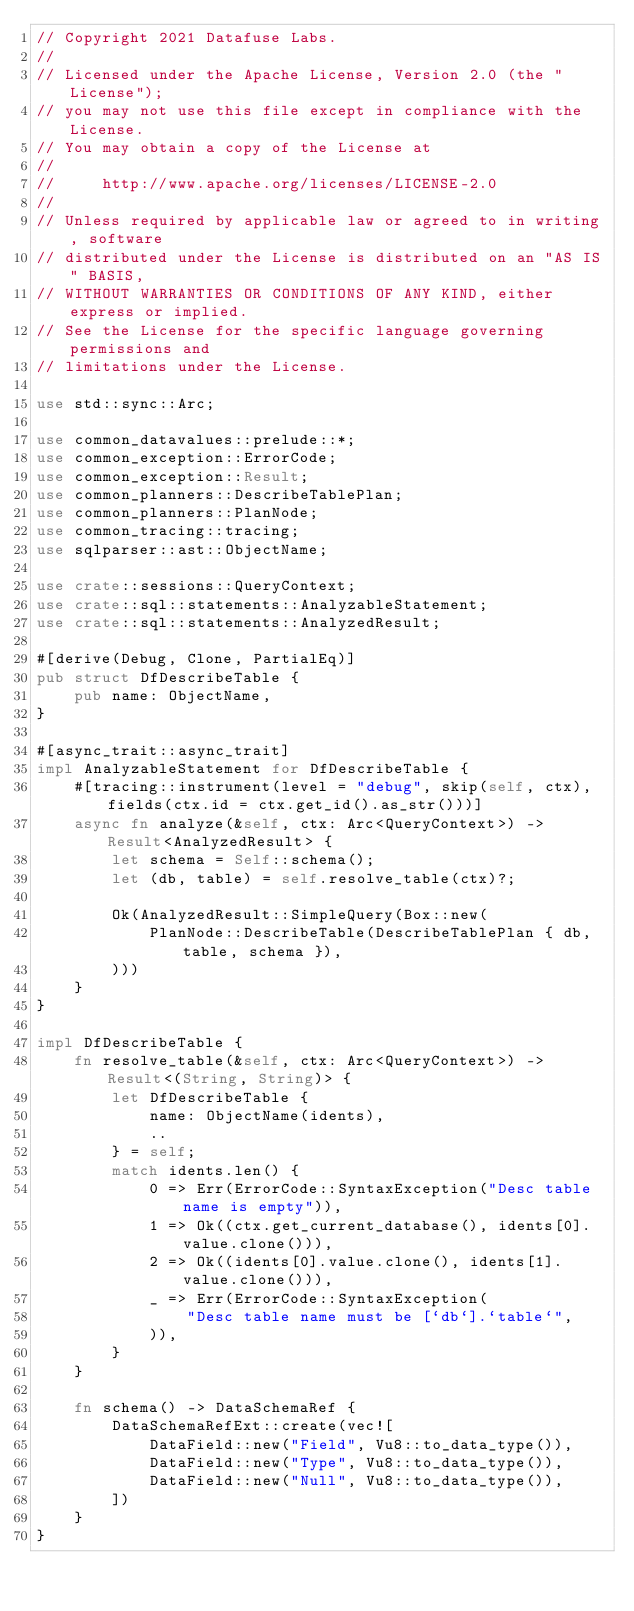<code> <loc_0><loc_0><loc_500><loc_500><_Rust_>// Copyright 2021 Datafuse Labs.
//
// Licensed under the Apache License, Version 2.0 (the "License");
// you may not use this file except in compliance with the License.
// You may obtain a copy of the License at
//
//     http://www.apache.org/licenses/LICENSE-2.0
//
// Unless required by applicable law or agreed to in writing, software
// distributed under the License is distributed on an "AS IS" BASIS,
// WITHOUT WARRANTIES OR CONDITIONS OF ANY KIND, either express or implied.
// See the License for the specific language governing permissions and
// limitations under the License.

use std::sync::Arc;

use common_datavalues::prelude::*;
use common_exception::ErrorCode;
use common_exception::Result;
use common_planners::DescribeTablePlan;
use common_planners::PlanNode;
use common_tracing::tracing;
use sqlparser::ast::ObjectName;

use crate::sessions::QueryContext;
use crate::sql::statements::AnalyzableStatement;
use crate::sql::statements::AnalyzedResult;

#[derive(Debug, Clone, PartialEq)]
pub struct DfDescribeTable {
    pub name: ObjectName,
}

#[async_trait::async_trait]
impl AnalyzableStatement for DfDescribeTable {
    #[tracing::instrument(level = "debug", skip(self, ctx), fields(ctx.id = ctx.get_id().as_str()))]
    async fn analyze(&self, ctx: Arc<QueryContext>) -> Result<AnalyzedResult> {
        let schema = Self::schema();
        let (db, table) = self.resolve_table(ctx)?;

        Ok(AnalyzedResult::SimpleQuery(Box::new(
            PlanNode::DescribeTable(DescribeTablePlan { db, table, schema }),
        )))
    }
}

impl DfDescribeTable {
    fn resolve_table(&self, ctx: Arc<QueryContext>) -> Result<(String, String)> {
        let DfDescribeTable {
            name: ObjectName(idents),
            ..
        } = self;
        match idents.len() {
            0 => Err(ErrorCode::SyntaxException("Desc table name is empty")),
            1 => Ok((ctx.get_current_database(), idents[0].value.clone())),
            2 => Ok((idents[0].value.clone(), idents[1].value.clone())),
            _ => Err(ErrorCode::SyntaxException(
                "Desc table name must be [`db`].`table`",
            )),
        }
    }

    fn schema() -> DataSchemaRef {
        DataSchemaRefExt::create(vec![
            DataField::new("Field", Vu8::to_data_type()),
            DataField::new("Type", Vu8::to_data_type()),
            DataField::new("Null", Vu8::to_data_type()),
        ])
    }
}
</code> 